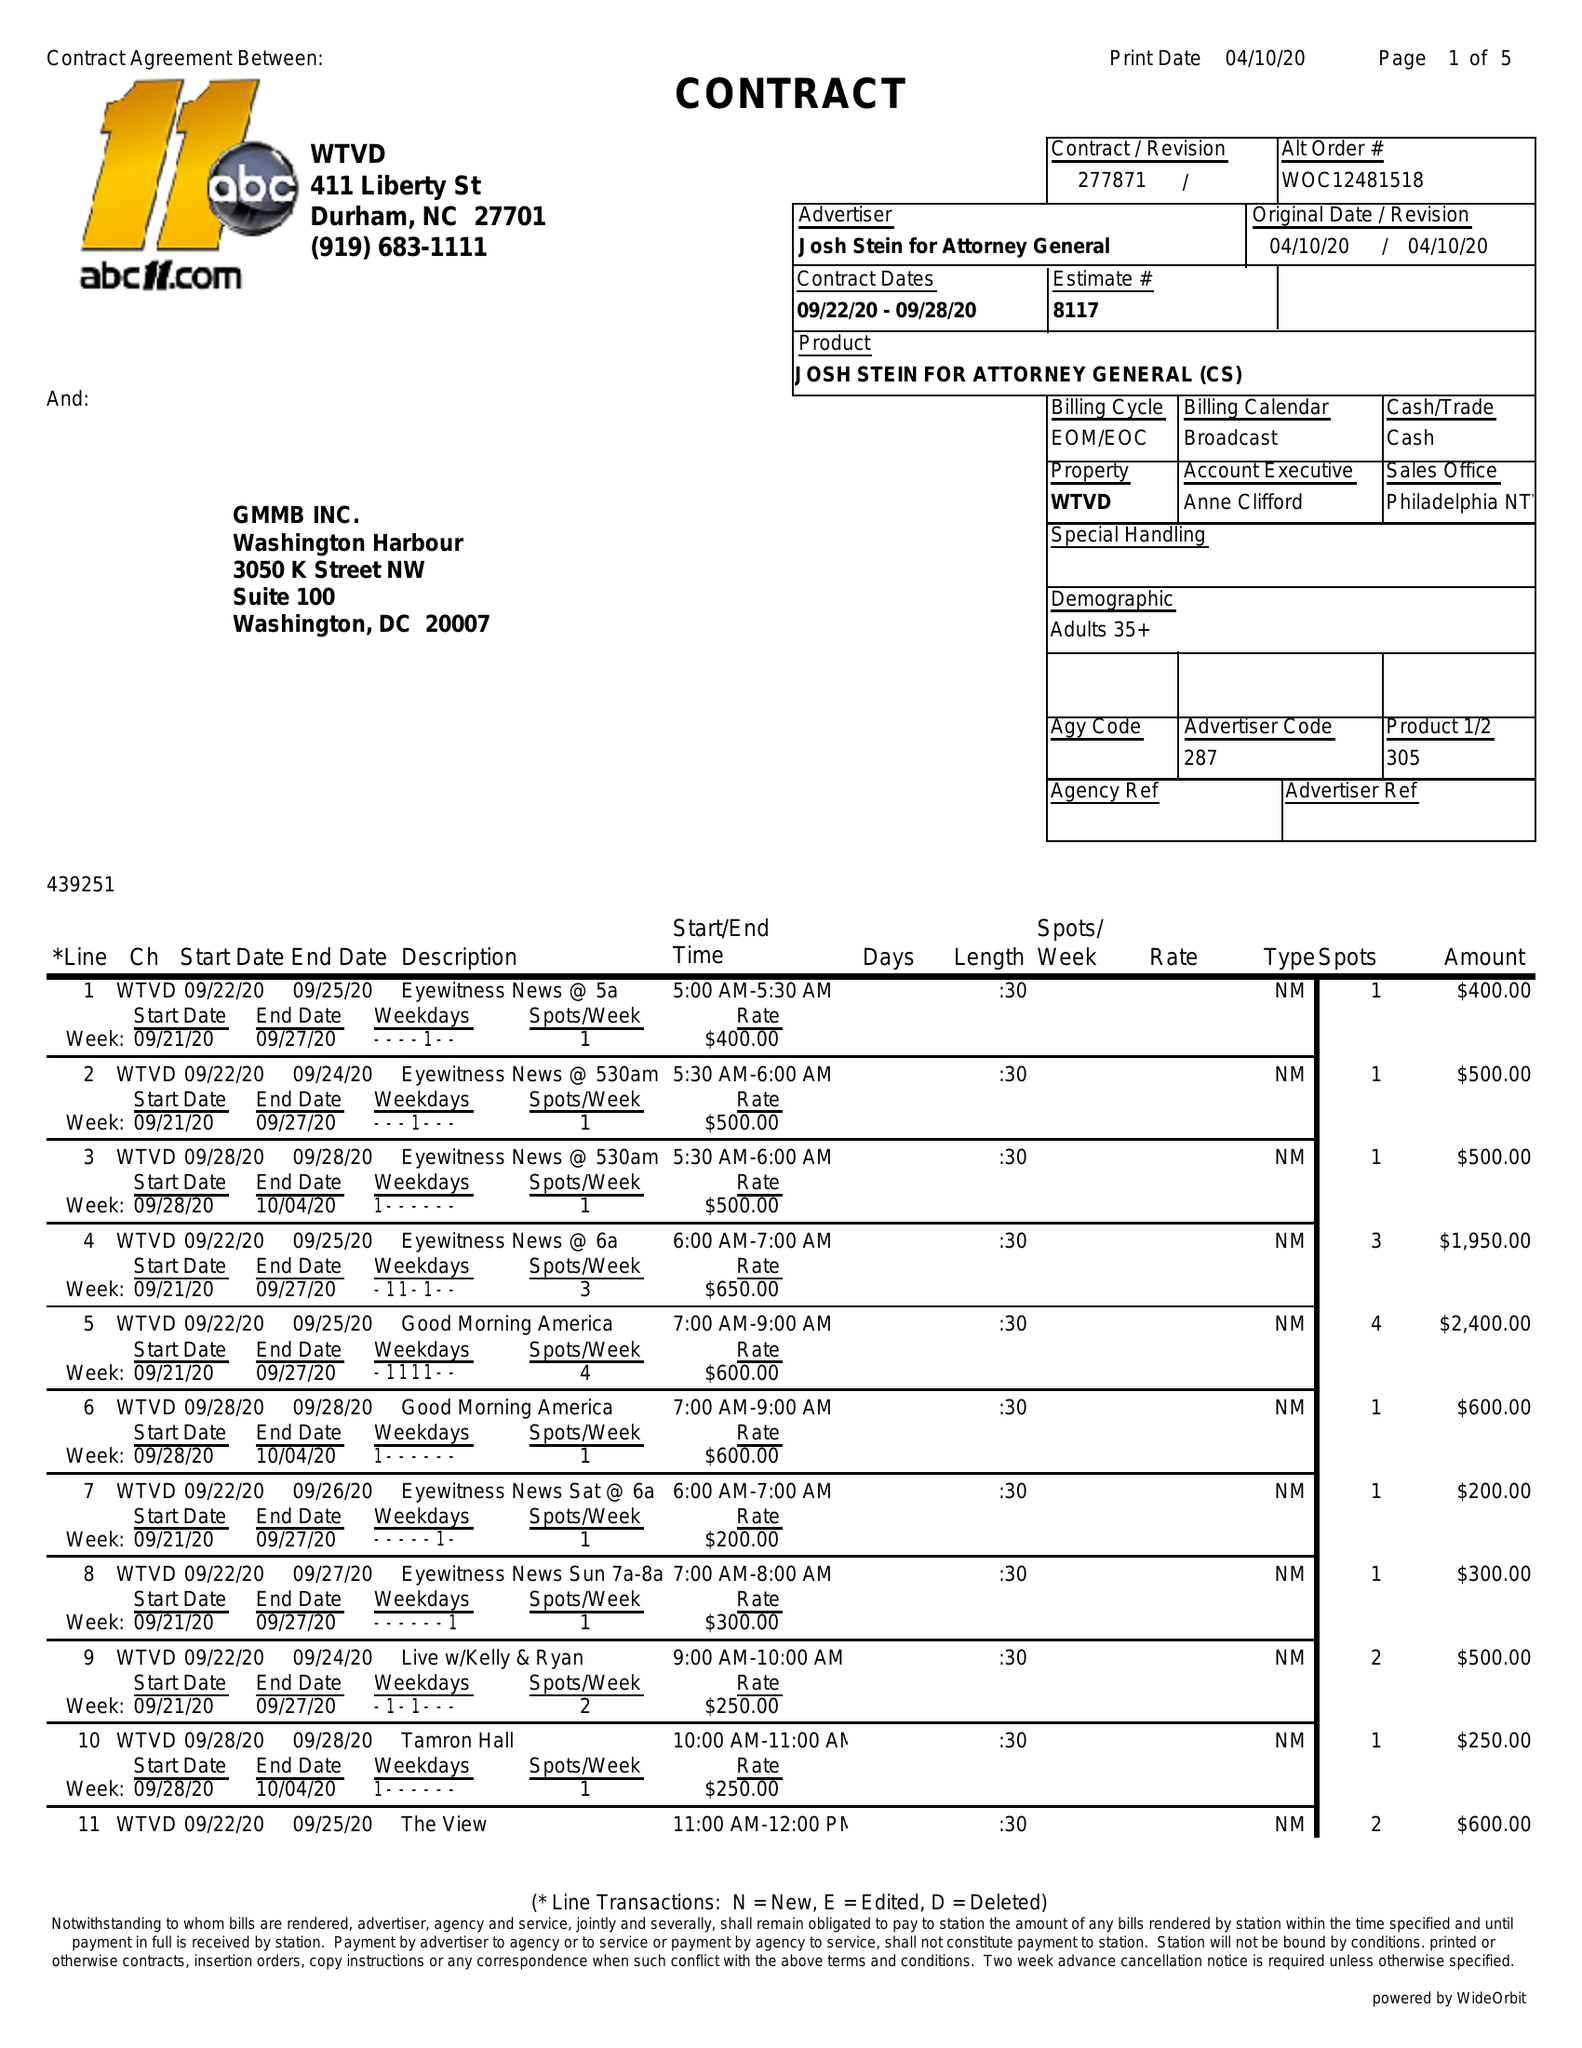What is the value for the advertiser?
Answer the question using a single word or phrase. JOSH STEIN FOR ATTORNEY GENERAL 